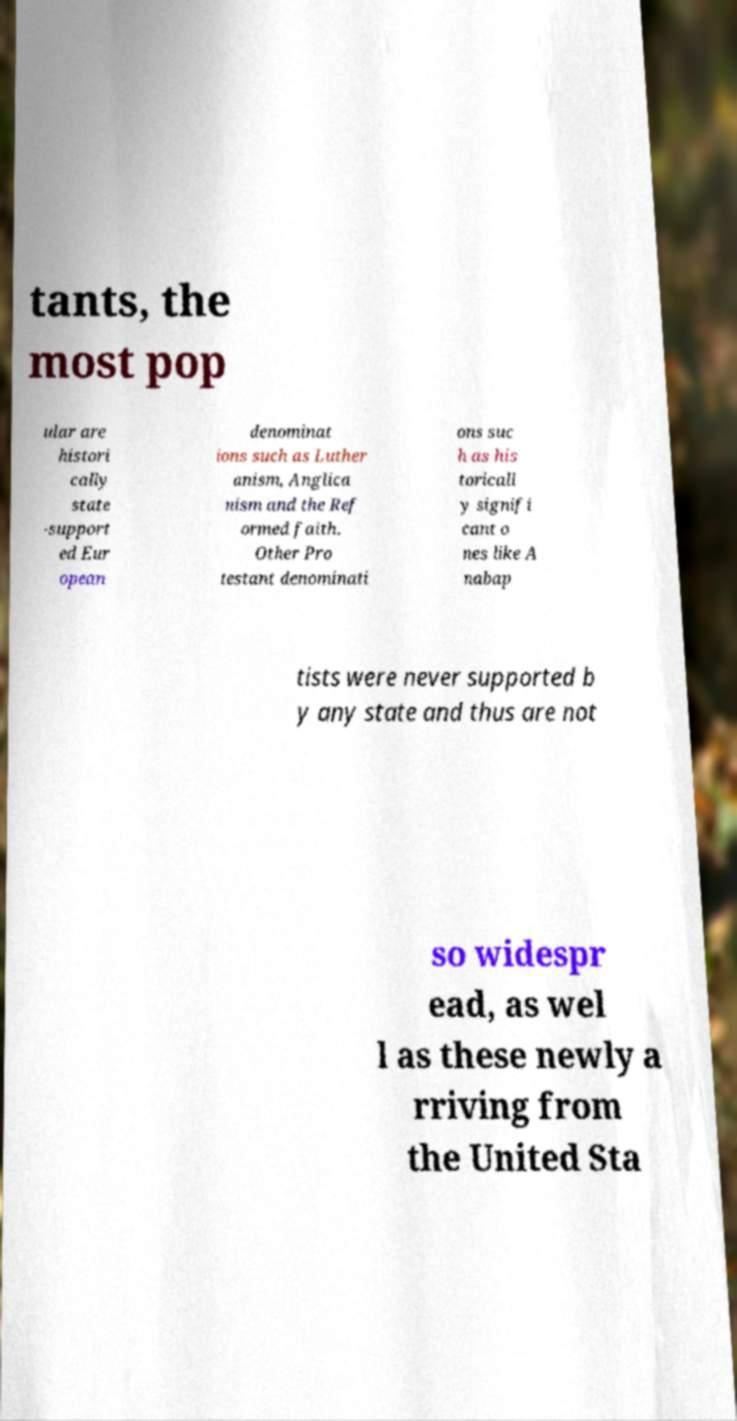Can you read and provide the text displayed in the image?This photo seems to have some interesting text. Can you extract and type it out for me? tants, the most pop ular are histori cally state -support ed Eur opean denominat ions such as Luther anism, Anglica nism and the Ref ormed faith. Other Pro testant denominati ons suc h as his toricall y signifi cant o nes like A nabap tists were never supported b y any state and thus are not so widespr ead, as wel l as these newly a rriving from the United Sta 